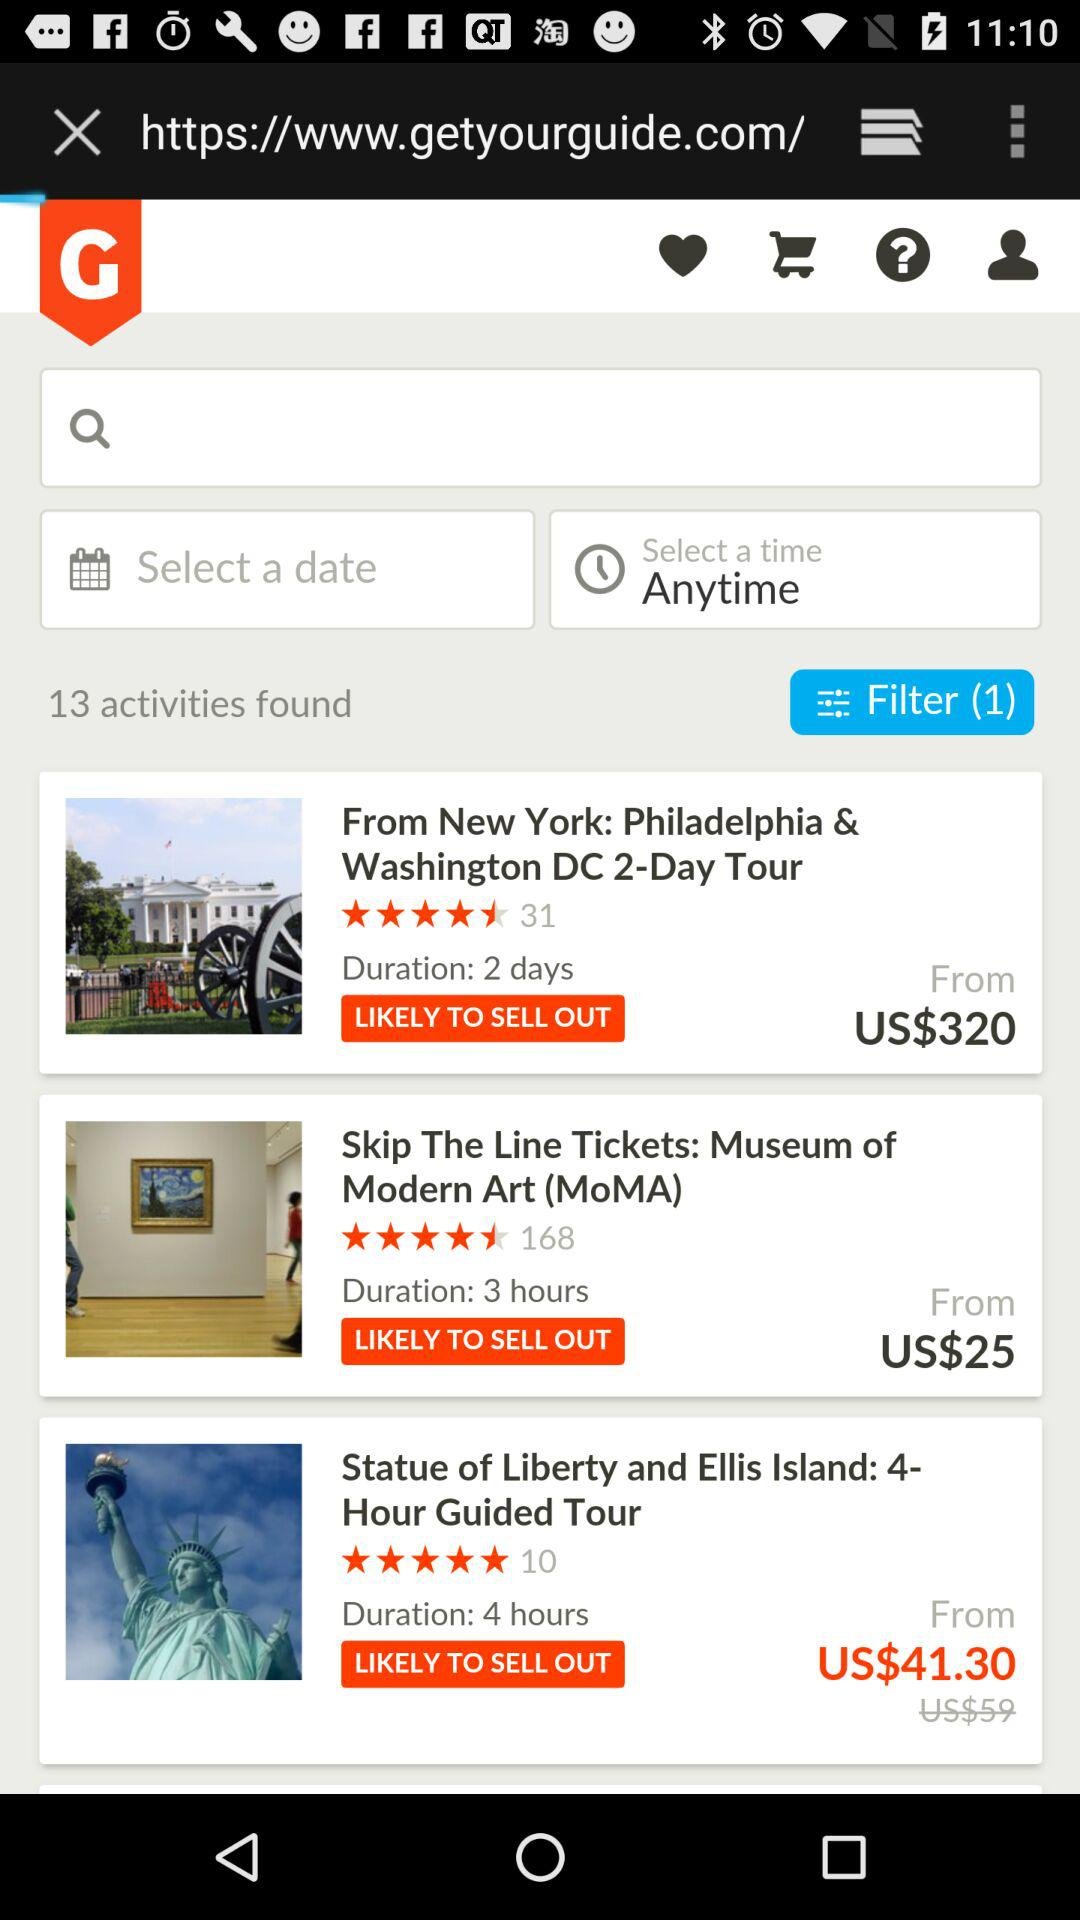How many activities are shown on the screen?
Answer the question using a single word or phrase. 3 